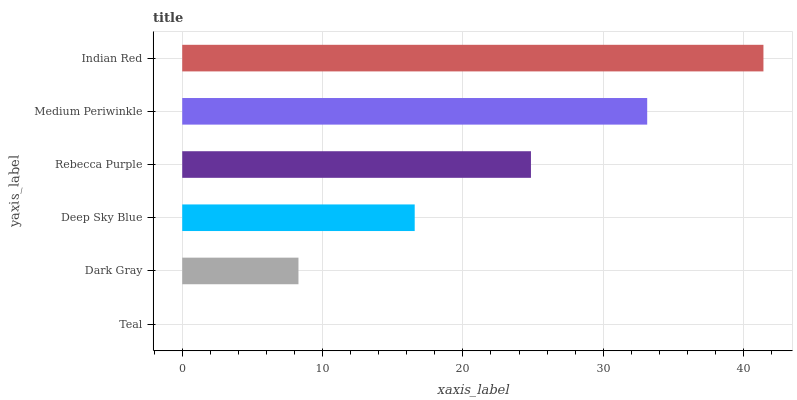Is Teal the minimum?
Answer yes or no. Yes. Is Indian Red the maximum?
Answer yes or no. Yes. Is Dark Gray the minimum?
Answer yes or no. No. Is Dark Gray the maximum?
Answer yes or no. No. Is Dark Gray greater than Teal?
Answer yes or no. Yes. Is Teal less than Dark Gray?
Answer yes or no. Yes. Is Teal greater than Dark Gray?
Answer yes or no. No. Is Dark Gray less than Teal?
Answer yes or no. No. Is Rebecca Purple the high median?
Answer yes or no. Yes. Is Deep Sky Blue the low median?
Answer yes or no. Yes. Is Deep Sky Blue the high median?
Answer yes or no. No. Is Indian Red the low median?
Answer yes or no. No. 